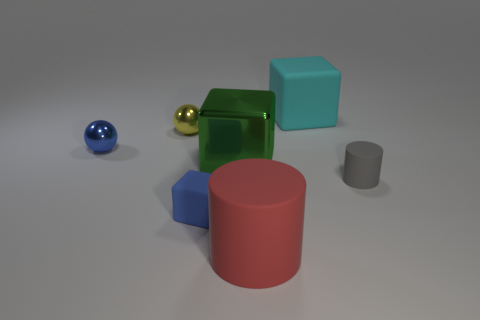Add 1 small blocks. How many objects exist? 8 Subtract all cylinders. How many objects are left? 5 Subtract all large gray metallic blocks. Subtract all big red things. How many objects are left? 6 Add 3 rubber cylinders. How many rubber cylinders are left? 5 Add 2 large red cylinders. How many large red cylinders exist? 3 Subtract 0 gray spheres. How many objects are left? 7 